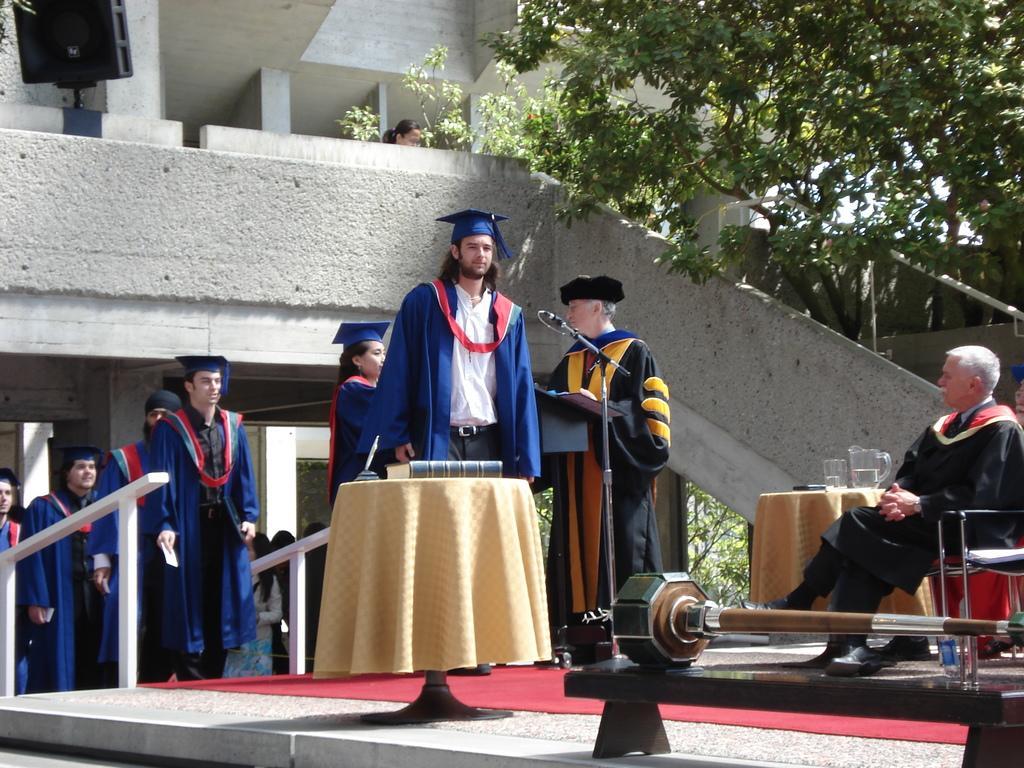Describe this image in one or two sentences. This picture describes about group of people, few people wore caps, in front of them we can see a microphone and a book on the table, on the right side of the image we can see a man, he is seated on the chair, beside to him we can see a jug and a glass on the table, in the background we can see a tree and a building. 